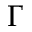Convert formula to latex. <formula><loc_0><loc_0><loc_500><loc_500>\Gamma</formula> 